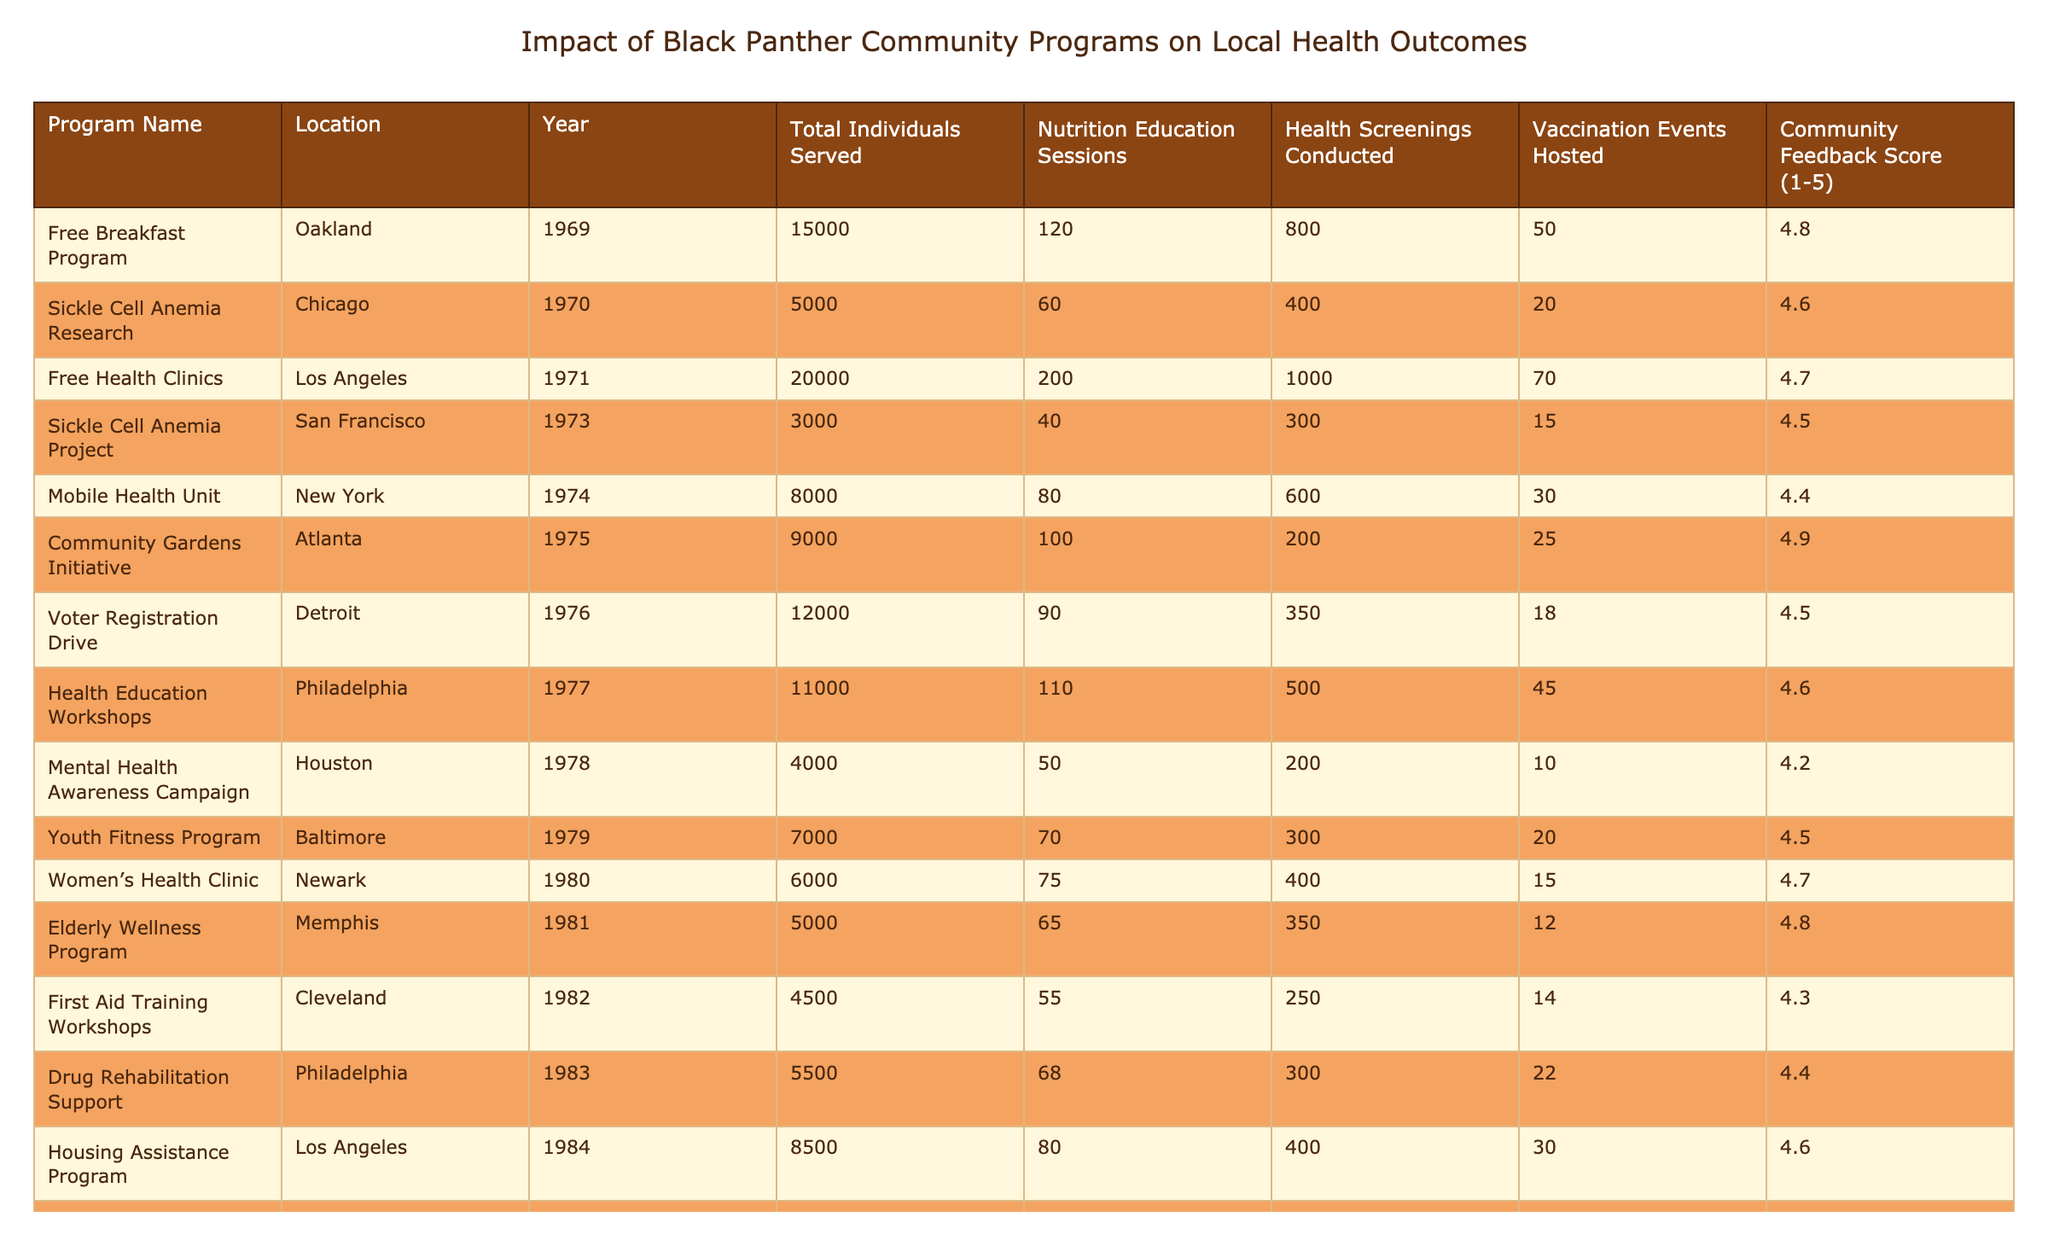What is the highest Community Feedback Score in the table? The highest Community Feedback Score can be found by scanning through the values in the last column. The maximum value is 4.9, which is associated with both the Free Breakfast Program and the Community Gardens Initiative.
Answer: 4.9 How many health screenings were conducted through the Free Health Clinics program? To answer this, locate the row for the Free Health Clinics program and find the value in the "Health Screenings Conducted" column, which is recorded as 1000.
Answer: 1000 What is the total number of individuals served by the programs in Los Angeles? Identify the programs located in Los Angeles: Free Health Clinics and Housing Assistance Program. The total number of individuals served is 20000 (Free Health Clinics) + 8500 (Housing Assistance Program) = 28500.
Answer: 28500 Which program conducted the lowest number of health screenings and what was the number? Review the "Health Screenings Conducted" column. The Sickle Cell Anemia Project in San Francisco has the lowest number of health screenings at 300.
Answer: 300 Is there a correlation between the number of nutrition education sessions and the community feedback score? Look at the nutrition education sessions and corresponding community feedback scores. For example, the Free Breakfast Program has 120 sessions and a score of 4.8. After comparing such pairs, it appears a pattern suggests that a higher number of sessions correlates with higher scores, but a statistical analysis would confirm this appropriately.
Answer: Yes (suggested relationship) What is the average number of vaccination events hosted across all programs? Add the number of vaccination events hosted for each program: 50 + 20 + 70 + 15 + 30 + 25 + 18 + 10 + 20 + 15 + 12 + 14 + 30 + 28 + 16 + 35 + 12 + 20 + 40 =  470. Then divide by the number of programs (18) to find the average, which is 470/18 ≈ 26.1.
Answer: 26.1 Which city hosted the most community events in terms of health screenings? Review the "Health Screenings Conducted" column and identify the city with the highest single value. The Free Health Clinics in Los Angeles conducted 1000 screenings, more than any other program listed.
Answer: Los Angeles Count how many programs ran before the year 1980, and what was the average community feedback score for those programs? Identify the programs from the rows before 1980, which include 11 programs. Calculate the total community feedback score for these programs (4.8 + 4.6 + 4.7 + 4.5 + 4.4 + 4.9 + 4.5 + 4.6 + 4.2 + 4.5 + 4.7) = 51.4 and divide by 11, yielding an average of 4.67.
Answer: 4.67 What is the relationship between the year of the program and the total individuals served? To explore this, compare the program years with the total individuals served across the table; older programs do not necessarily correlate to higher individual counts, as the Free Health Clinics in 1971 served the most individuals at 20000, indicating that more recent programs did not always serve more individuals.
Answer: No clear relationship 